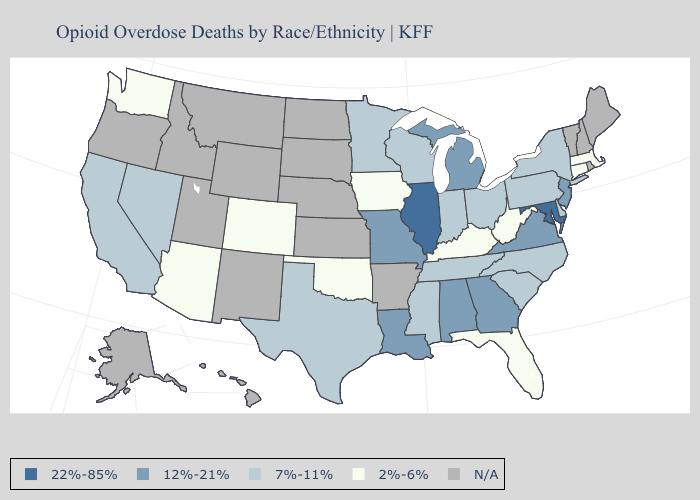Among the states that border West Virginia , does Maryland have the highest value?
Write a very short answer. Yes. Name the states that have a value in the range N/A?
Write a very short answer. Alaska, Arkansas, Hawaii, Idaho, Kansas, Maine, Montana, Nebraska, New Hampshire, New Mexico, North Dakota, Oregon, Rhode Island, South Dakota, Utah, Vermont, Wyoming. What is the lowest value in the USA?
Be succinct. 2%-6%. Name the states that have a value in the range 22%-85%?
Keep it brief. Illinois, Maryland. Does Illinois have the highest value in the MidWest?
Write a very short answer. Yes. Which states have the lowest value in the USA?
Answer briefly. Arizona, Colorado, Connecticut, Florida, Iowa, Kentucky, Massachusetts, Oklahoma, Washington, West Virginia. Which states have the lowest value in the West?
Be succinct. Arizona, Colorado, Washington. What is the value of Mississippi?
Concise answer only. 7%-11%. What is the lowest value in the MidWest?
Quick response, please. 2%-6%. Does the map have missing data?
Concise answer only. Yes. What is the lowest value in states that border Indiana?
Give a very brief answer. 2%-6%. Which states have the highest value in the USA?
Quick response, please. Illinois, Maryland. Does New Jersey have the lowest value in the USA?
Write a very short answer. No. What is the value of Massachusetts?
Write a very short answer. 2%-6%. What is the value of Florida?
Answer briefly. 2%-6%. 